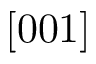<formula> <loc_0><loc_0><loc_500><loc_500>[ 0 0 1 ]</formula> 